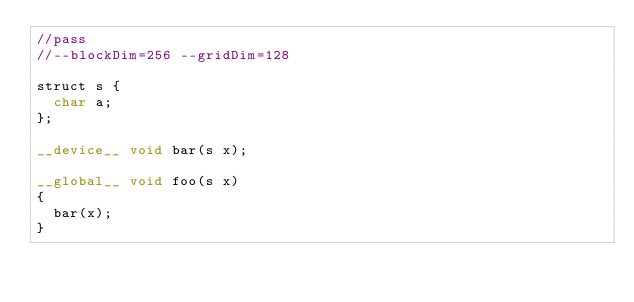Convert code to text. <code><loc_0><loc_0><loc_500><loc_500><_Cuda_>//pass
//--blockDim=256 --gridDim=128

struct s {
  char a;
};

__device__ void bar(s x);

__global__ void foo(s x)
{
  bar(x);
}
</code> 